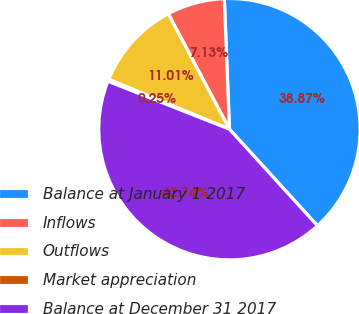Convert chart. <chart><loc_0><loc_0><loc_500><loc_500><pie_chart><fcel>Balance at January 1 2017<fcel>Inflows<fcel>Outflows<fcel>Market appreciation<fcel>Balance at December 31 2017<nl><fcel>38.87%<fcel>7.13%<fcel>11.01%<fcel>0.25%<fcel>42.74%<nl></chart> 